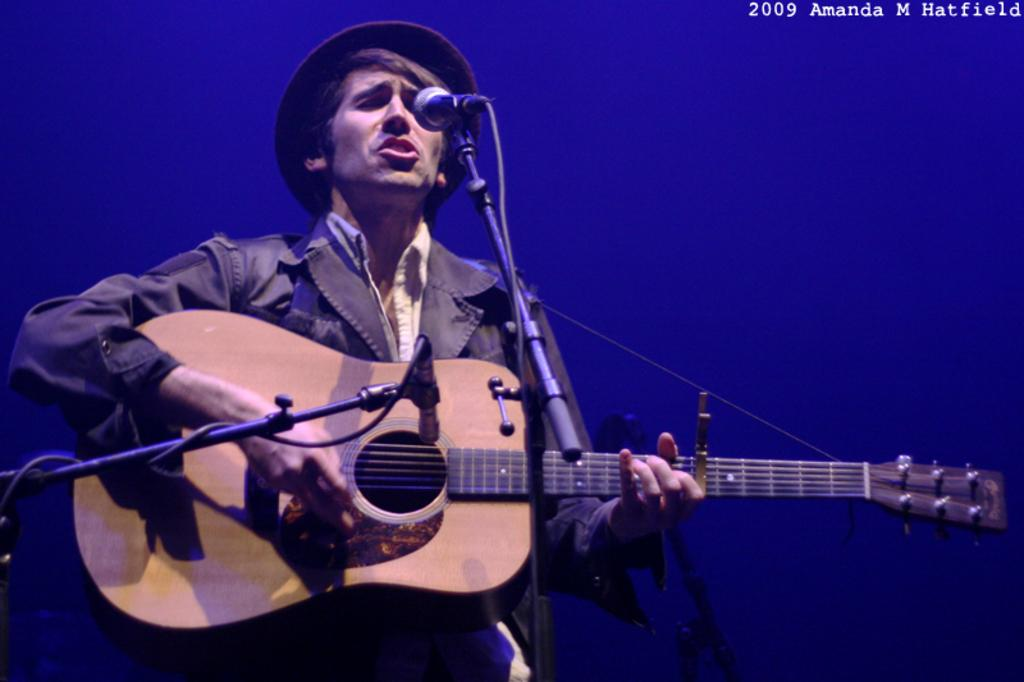What is the main subject of the image? There is a person in the image. What is the person doing in the image? The person is playing a guitar and singing on a mic. What type of top is the person wearing in the image? There is no information about the person's clothing in the provided facts, so we cannot determine the type of top they are wearing. 